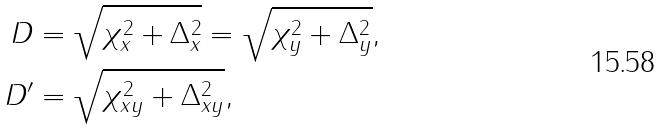Convert formula to latex. <formula><loc_0><loc_0><loc_500><loc_500>D & = \sqrt { \chi _ { x } ^ { 2 } + \Delta _ { x } ^ { 2 } } = \sqrt { \chi _ { y } ^ { 2 } + \Delta _ { y } ^ { 2 } } , \\ D ^ { \prime } & = \sqrt { \chi _ { x y } ^ { 2 } + \Delta _ { x y } ^ { 2 } } ,</formula> 